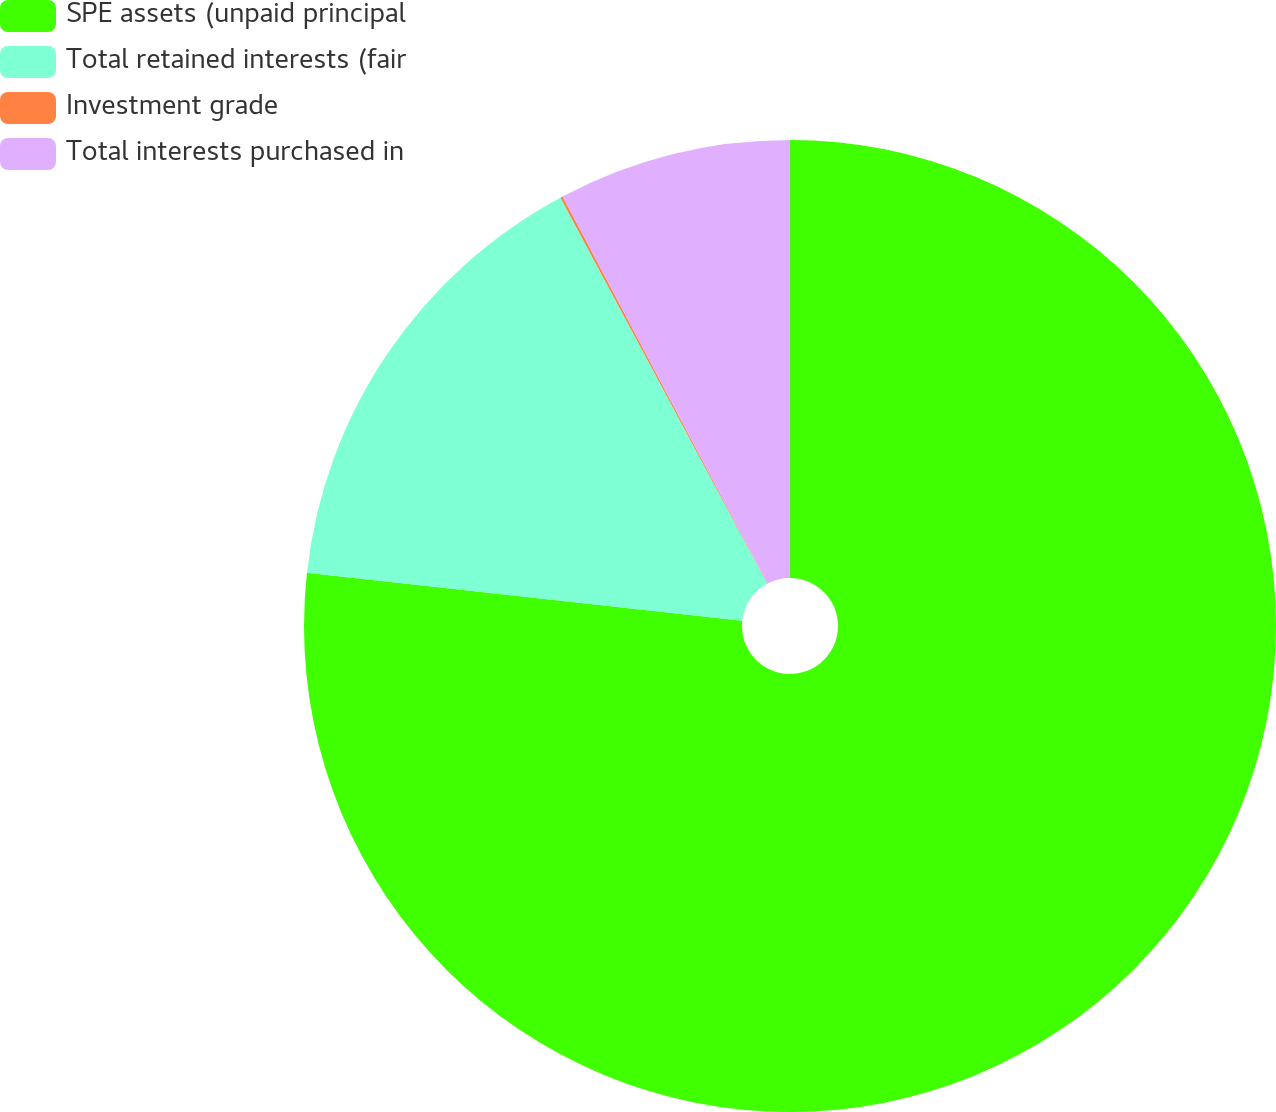Convert chart to OTSL. <chart><loc_0><loc_0><loc_500><loc_500><pie_chart><fcel>SPE assets (unpaid principal<fcel>Total retained interests (fair<fcel>Investment grade<fcel>Total interests purchased in<nl><fcel>76.75%<fcel>15.42%<fcel>0.08%<fcel>7.75%<nl></chart> 